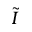<formula> <loc_0><loc_0><loc_500><loc_500>\tilde { I }</formula> 